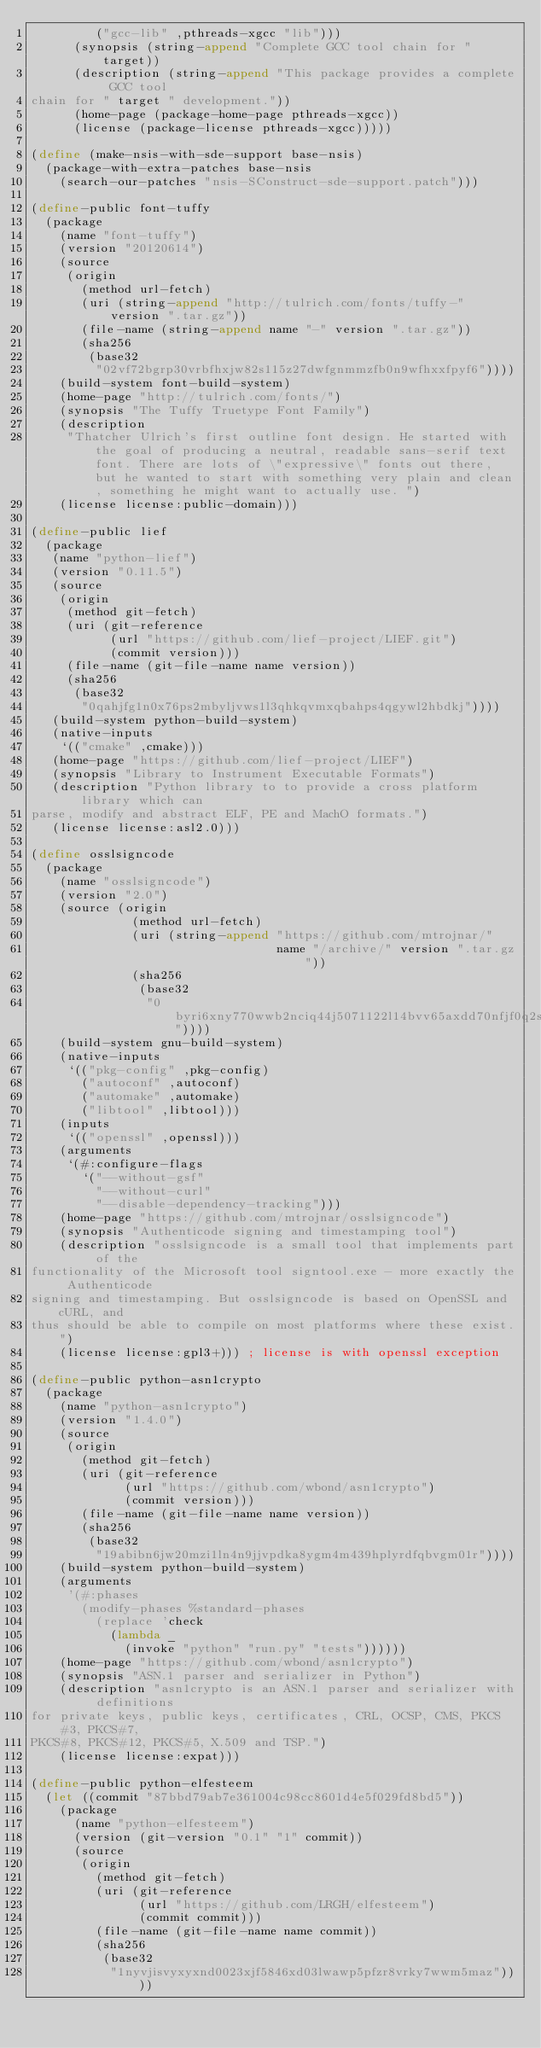<code> <loc_0><loc_0><loc_500><loc_500><_Scheme_>         ("gcc-lib" ,pthreads-xgcc "lib")))
      (synopsis (string-append "Complete GCC tool chain for " target))
      (description (string-append "This package provides a complete GCC tool
chain for " target " development."))
      (home-page (package-home-page pthreads-xgcc))
      (license (package-license pthreads-xgcc)))))

(define (make-nsis-with-sde-support base-nsis)
  (package-with-extra-patches base-nsis
    (search-our-patches "nsis-SConstruct-sde-support.patch")))

(define-public font-tuffy
  (package
    (name "font-tuffy")
    (version "20120614")
    (source
     (origin
       (method url-fetch)
       (uri (string-append "http://tulrich.com/fonts/tuffy-" version ".tar.gz"))
       (file-name (string-append name "-" version ".tar.gz"))
       (sha256
        (base32
         "02vf72bgrp30vrbfhxjw82s115z27dwfgnmmzfb0n9wfhxxfpyf6"))))
    (build-system font-build-system)
    (home-page "http://tulrich.com/fonts/")
    (synopsis "The Tuffy Truetype Font Family")
    (description
     "Thatcher Ulrich's first outline font design. He started with the goal of producing a neutral, readable sans-serif text font. There are lots of \"expressive\" fonts out there, but he wanted to start with something very plain and clean, something he might want to actually use. ")
    (license license:public-domain)))

(define-public lief
  (package
   (name "python-lief")
   (version "0.11.5")
   (source
    (origin
     (method git-fetch)
     (uri (git-reference
           (url "https://github.com/lief-project/LIEF.git")
           (commit version)))
     (file-name (git-file-name name version))
     (sha256
      (base32
       "0qahjfg1n0x76ps2mbyljvws1l3qhkqvmxqbahps4qgywl2hbdkj"))))
   (build-system python-build-system)
   (native-inputs
    `(("cmake" ,cmake)))
   (home-page "https://github.com/lief-project/LIEF")
   (synopsis "Library to Instrument Executable Formats")
   (description "Python library to to provide a cross platform library which can
parse, modify and abstract ELF, PE and MachO formats.")
   (license license:asl2.0)))

(define osslsigncode
  (package
    (name "osslsigncode")
    (version "2.0")
    (source (origin
              (method url-fetch)
              (uri (string-append "https://github.com/mtrojnar/"
                                  name "/archive/" version ".tar.gz"))
              (sha256
               (base32
                "0byri6xny770wwb2nciq44j5071122l14bvv65axdd70nfjf0q2s"))))
    (build-system gnu-build-system)
    (native-inputs
     `(("pkg-config" ,pkg-config)
       ("autoconf" ,autoconf)
       ("automake" ,automake)
       ("libtool" ,libtool)))
    (inputs
     `(("openssl" ,openssl)))
    (arguments
     `(#:configure-flags
       `("--without-gsf"
         "--without-curl"
         "--disable-dependency-tracking")))
    (home-page "https://github.com/mtrojnar/osslsigncode")
    (synopsis "Authenticode signing and timestamping tool")
    (description "osslsigncode is a small tool that implements part of the
functionality of the Microsoft tool signtool.exe - more exactly the Authenticode
signing and timestamping. But osslsigncode is based on OpenSSL and cURL, and
thus should be able to compile on most platforms where these exist.")
    (license license:gpl3+))) ; license is with openssl exception

(define-public python-asn1crypto
  (package
    (name "python-asn1crypto")
    (version "1.4.0")
    (source
     (origin
       (method git-fetch)
       (uri (git-reference
             (url "https://github.com/wbond/asn1crypto")
             (commit version)))
       (file-name (git-file-name name version))
       (sha256
        (base32
         "19abibn6jw20mzi1ln4n9jjvpdka8ygm4m439hplyrdfqbvgm01r"))))
    (build-system python-build-system)
    (arguments
     '(#:phases
       (modify-phases %standard-phases
         (replace 'check
           (lambda _
             (invoke "python" "run.py" "tests"))))))
    (home-page "https://github.com/wbond/asn1crypto")
    (synopsis "ASN.1 parser and serializer in Python")
    (description "asn1crypto is an ASN.1 parser and serializer with definitions
for private keys, public keys, certificates, CRL, OCSP, CMS, PKCS#3, PKCS#7,
PKCS#8, PKCS#12, PKCS#5, X.509 and TSP.")
    (license license:expat)))

(define-public python-elfesteem
  (let ((commit "87bbd79ab7e361004c98cc8601d4e5f029fd8bd5"))
    (package
      (name "python-elfesteem")
      (version (git-version "0.1" "1" commit))
      (source
       (origin
         (method git-fetch)
         (uri (git-reference
               (url "https://github.com/LRGH/elfesteem")
               (commit commit)))
         (file-name (git-file-name name commit))
         (sha256
          (base32
           "1nyvjisvyxyxnd0023xjf5846xd03lwawp5pfzr8vrky7wwm5maz"))))</code> 